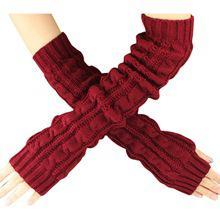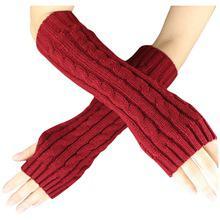The first image is the image on the left, the second image is the image on the right. For the images displayed, is the sentence "The left and right image contains the same of fingerless gloves." factually correct? Answer yes or no. Yes. The first image is the image on the left, the second image is the image on the right. Given the left and right images, does the statement "At least one pair of hand warmers is dark red." hold true? Answer yes or no. Yes. 